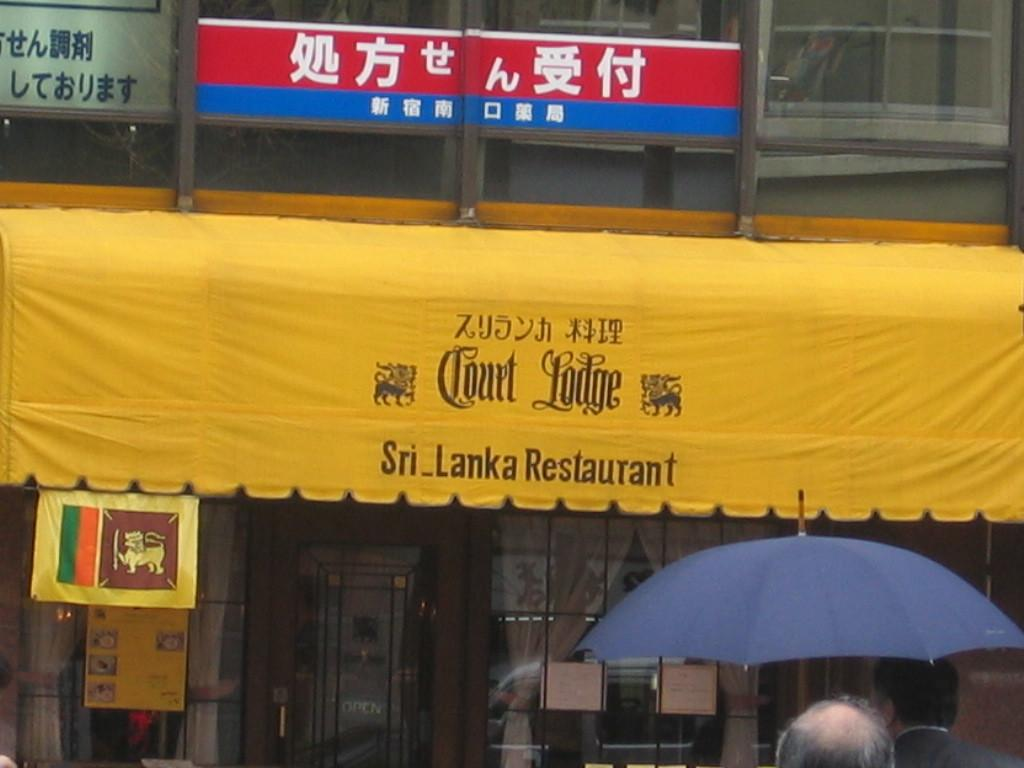Who or what can be seen in the image? There are people in the image. What object is present to provide shade or protection from the elements? There is an umbrella in the image. What can be seen in the distance in the background of the image? There is a building, a banner, and name boards in the background of the image. What type of bell can be heard ringing in the image? There is no bell present or audible in the image. Can you see any popcorn being sold or consumed in the image? There is no popcorn present in the image. 